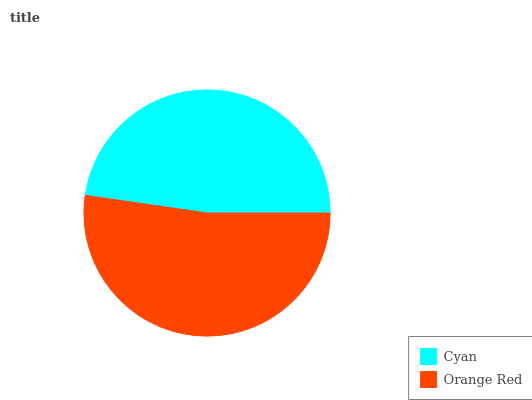Is Cyan the minimum?
Answer yes or no. Yes. Is Orange Red the maximum?
Answer yes or no. Yes. Is Orange Red the minimum?
Answer yes or no. No. Is Orange Red greater than Cyan?
Answer yes or no. Yes. Is Cyan less than Orange Red?
Answer yes or no. Yes. Is Cyan greater than Orange Red?
Answer yes or no. No. Is Orange Red less than Cyan?
Answer yes or no. No. Is Orange Red the high median?
Answer yes or no. Yes. Is Cyan the low median?
Answer yes or no. Yes. Is Cyan the high median?
Answer yes or no. No. Is Orange Red the low median?
Answer yes or no. No. 